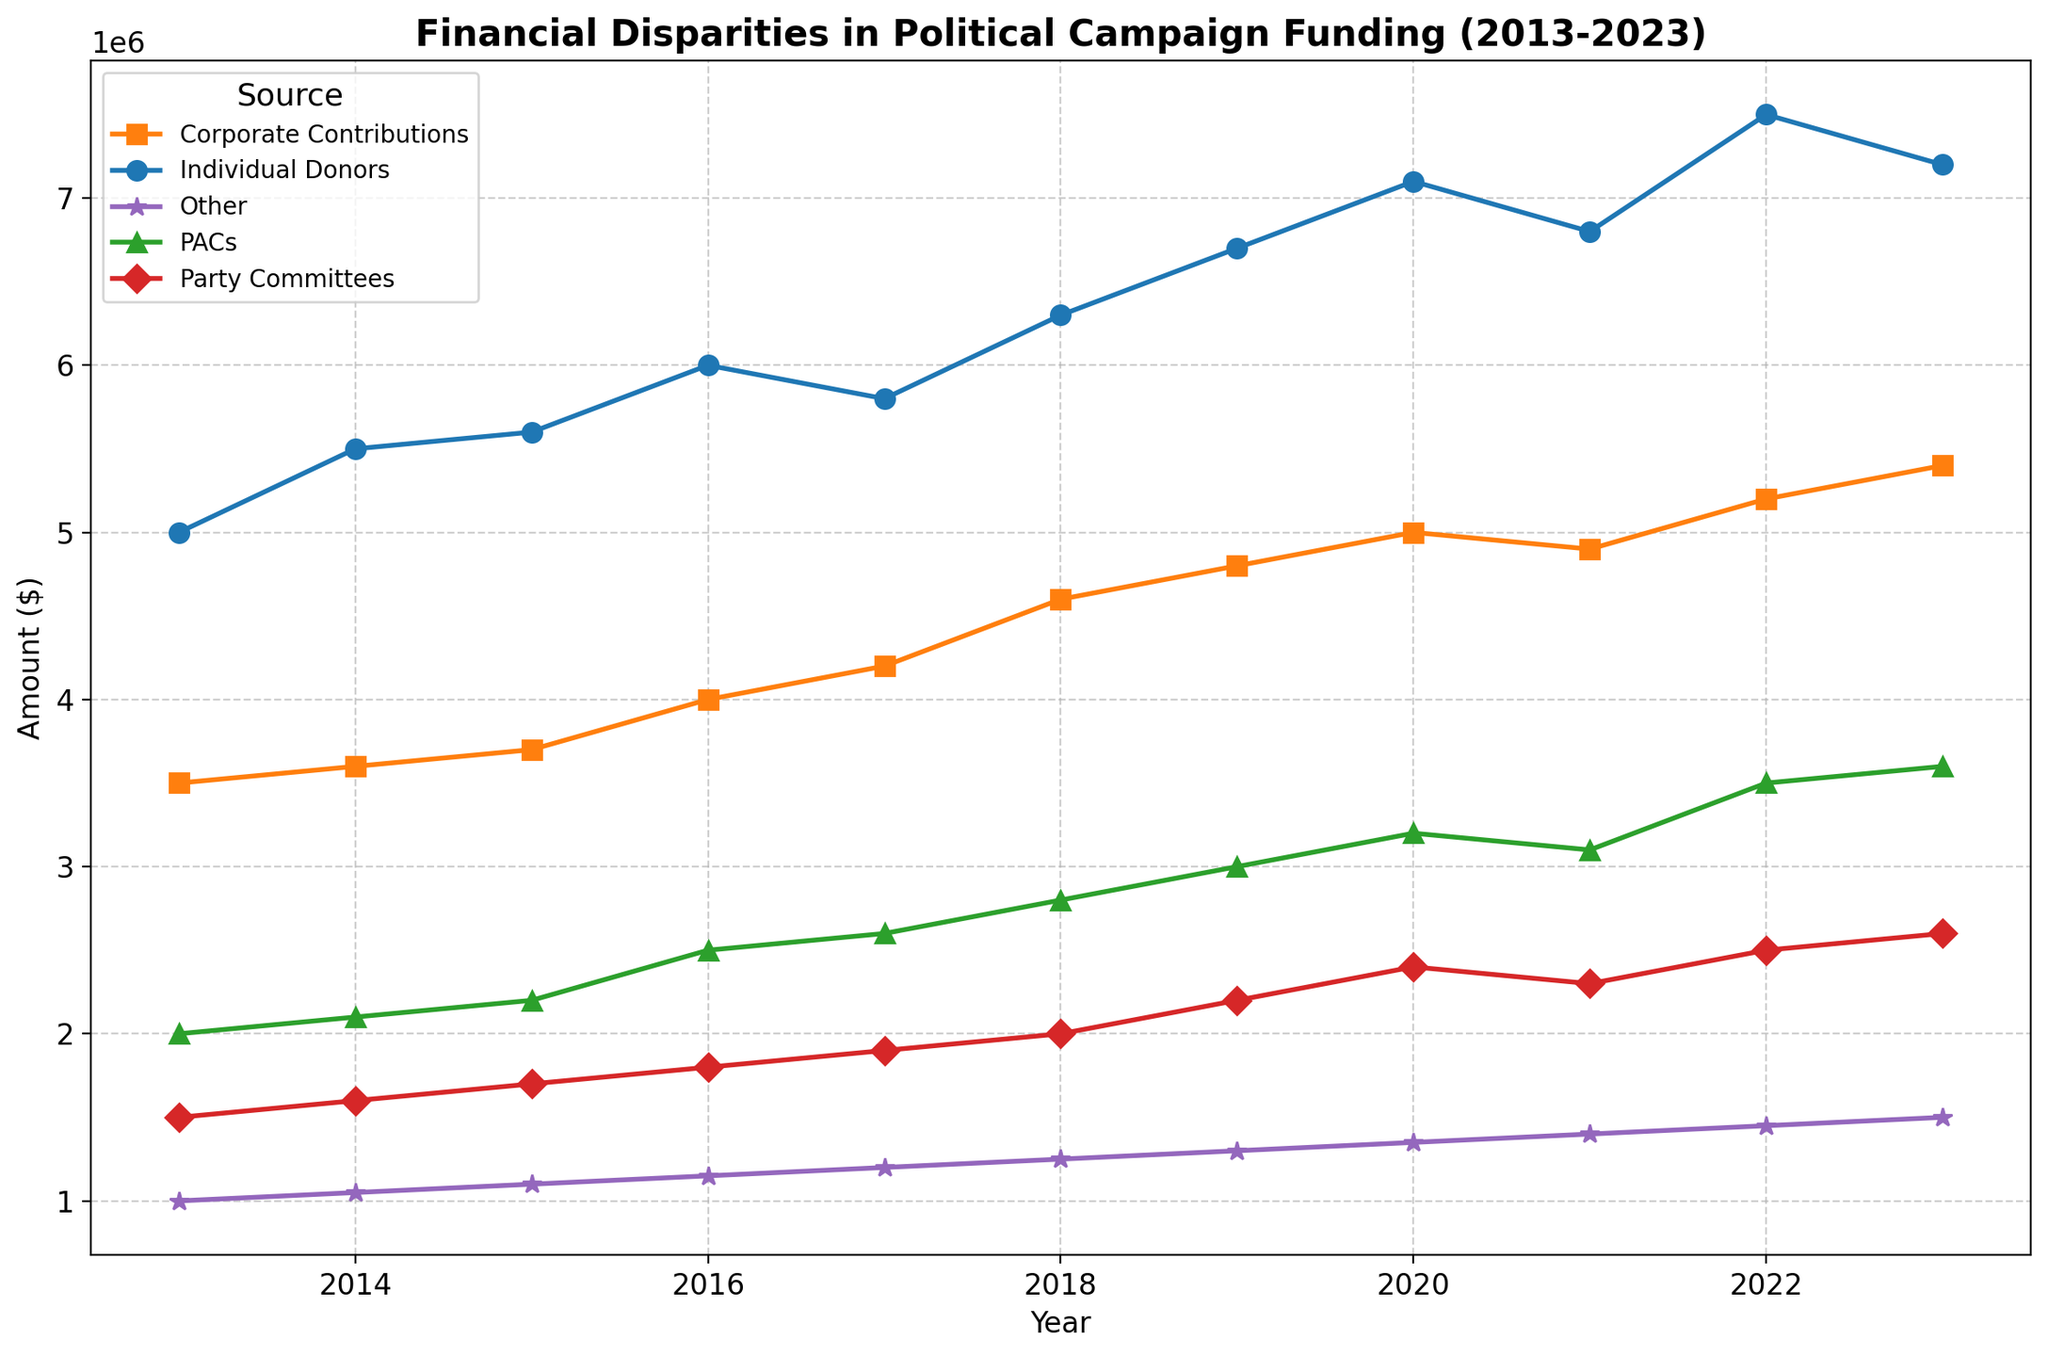What is the sum of PAC contributions and Party Committees funding in the year 2020? First, identify the value for PACs in 2020, which is $3,200,000. Then, find the value for Party Committees in 2020, which is $2,400,000. Sum these two values: $3,200,000 + $2,400,000 = $5,600,000.
Answer: $5,600,000 In which year did Individual Donors contribute the most, and how much was it? Observing the trend for Individual Donors, the maximum contribution is in 2022, where the value reaches $7,500,000.
Answer: 2022, $7,500,000 Compare the trend of Corporate Contributions and PACs from 2013 to 2023. How do they differ? Corporate Contributions consistently increase over the years without drastic drops, starting from $3,500,000 in 2013 to $5,400,000 in 2023. PACs also increase, but with more noticeable fluctuations, starting from $2,000,000 in 2013 and reaching $3,600,000 in 2023.
Answer: Corporate Contributions show steadier growth, while PACs have more fluctuations but overall increase What year(s) saw the highest combined contribution from Party Committees and Other sources? Calculate the combined contributions for Party Committees and Other sources for each year and compare. The combined amount ($2,950,000) is highest in 2023: Party Committees ($2,600,000) + Other ($1,500,000).
Answer: 2023 Which category consistently shows the highest contribution amount over the 10-year period? Following the lines, Individual Donors generally show the highest contribution amounts in each year compared to other categories.
Answer: Individual Donors Why do PAC contributions show a noticeable increase between 2016 and 2023? Observing the trend for PAC contributions, there is a significant rise starting from 2016 ($2,500,000) and continuing to 2023 ($3,600,000). Possible reasons could include increased lobbying activities, changes in political landscape, or changes in regulation.
Answer: PAC contributions increased due to various potential factors Which source shows the smallest variation in contributions over the years? By comparing the range of values for each category, Other contributions exhibit the least variation, remaining relatively constant and increasing moderately from $1,000,000 in 2013 to $1,500,000 in 2023.
Answer: Other In what year did all sources except Individual Donors show an increase in contributions? Reviewing the trends, each source except Individual Donors increased only in 2023. Individual Donors decrease slightly from 2022 ($7,500,000) to 2023 ($7,200,000) whereas others increased.
Answer: 2023 How does the contribution from Corporate Contributions in 2019 compare to the contribution from Individual Donors in 2018? Corporate Contributions in 2019 are $4,800,000 and Individual Donors in 2018 are $6,300,000. Comparing these, Individual Donors in 2018 contributed more by $1,500,000 ($6,300,000 - $4,800,000).
Answer: Individual Donors in 2018 contributed $1,500,000 more Which year shows the lowest contribution from Party Committees, and what is the value? Observing Party Committees values, the year with the lowest contribution is 2013 with $1,500,000.
Answer: 2013, $1,500,000 